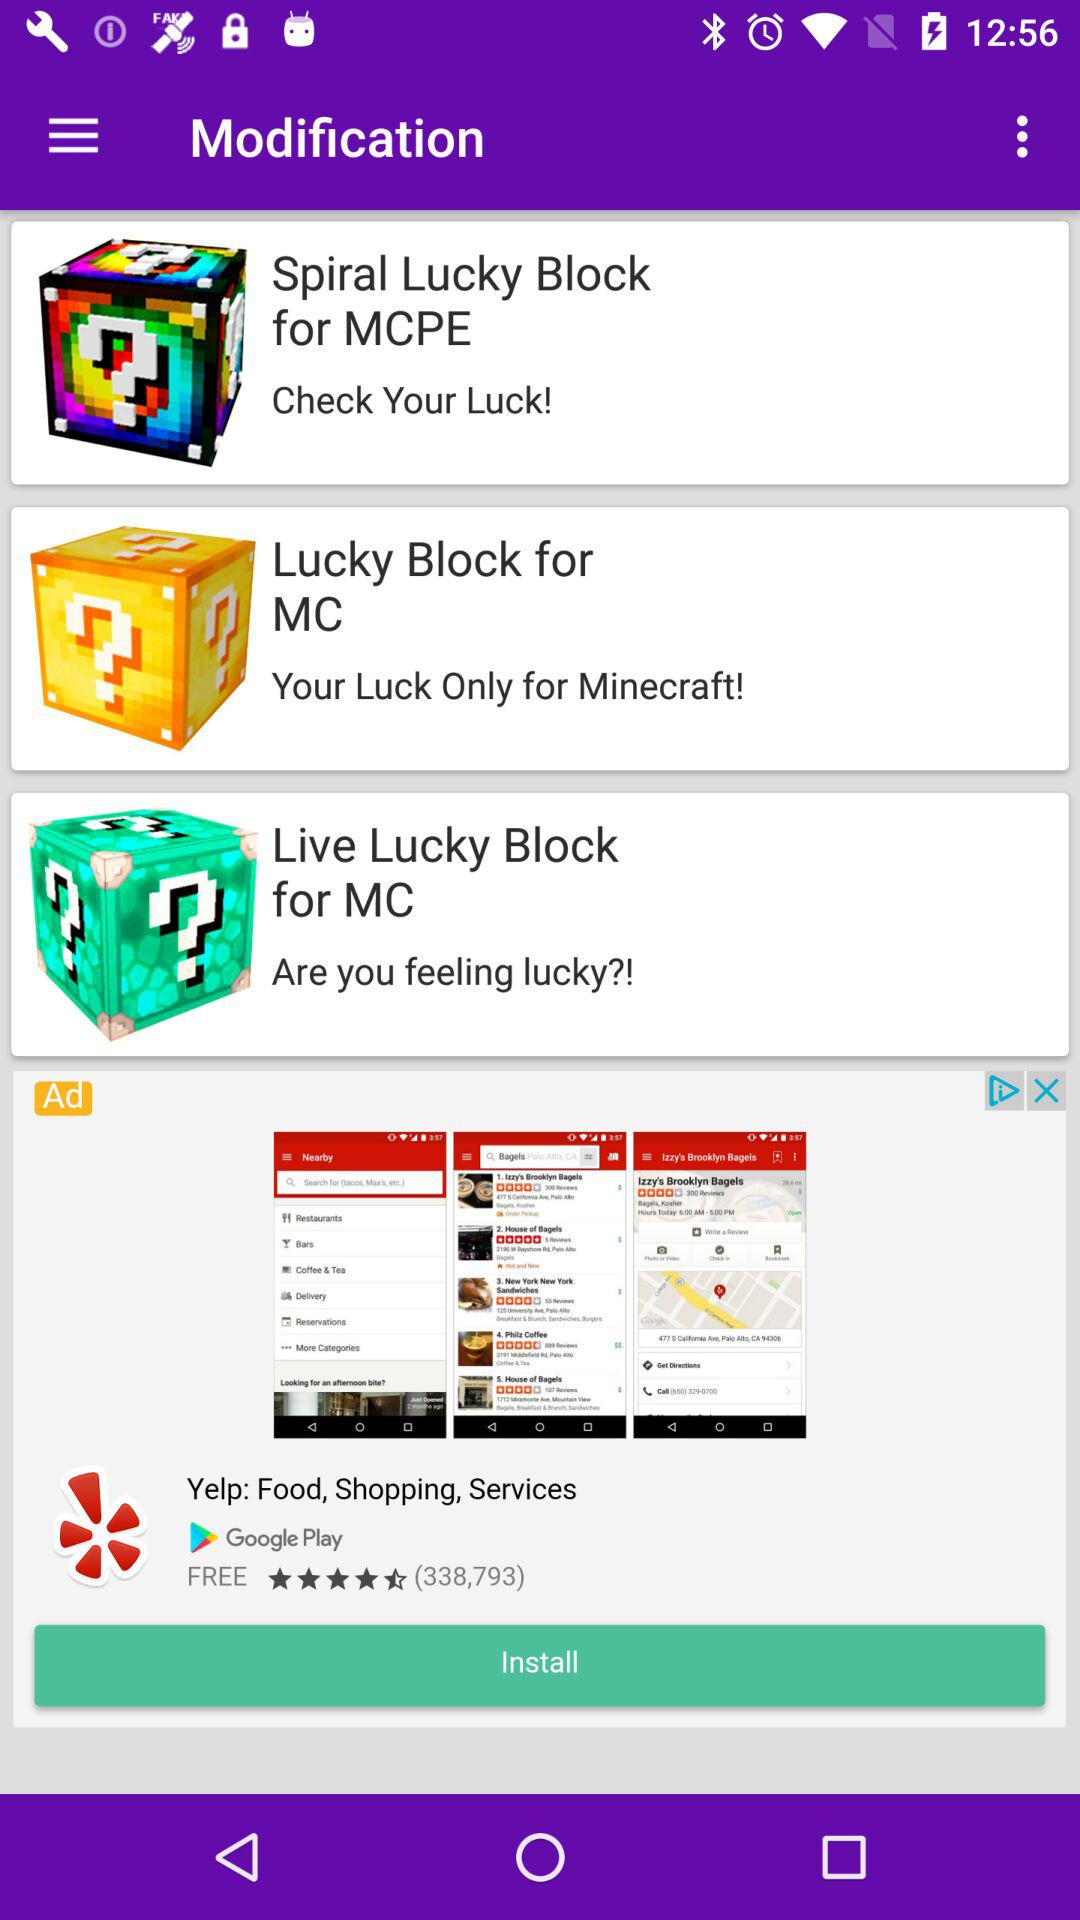How many app store screenshots are there?
Answer the question using a single word or phrase. 3 